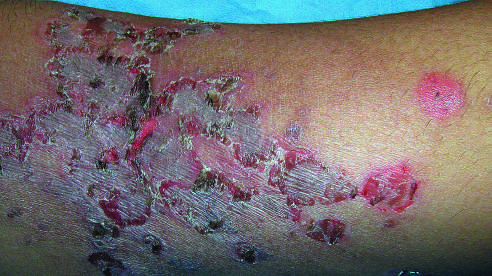re a majority of the tumor cells involved by a superficial bacterial infection showing the characteristic erythematous scablike lesions crusted with dried serum?
Answer the question using a single word or phrase. No 